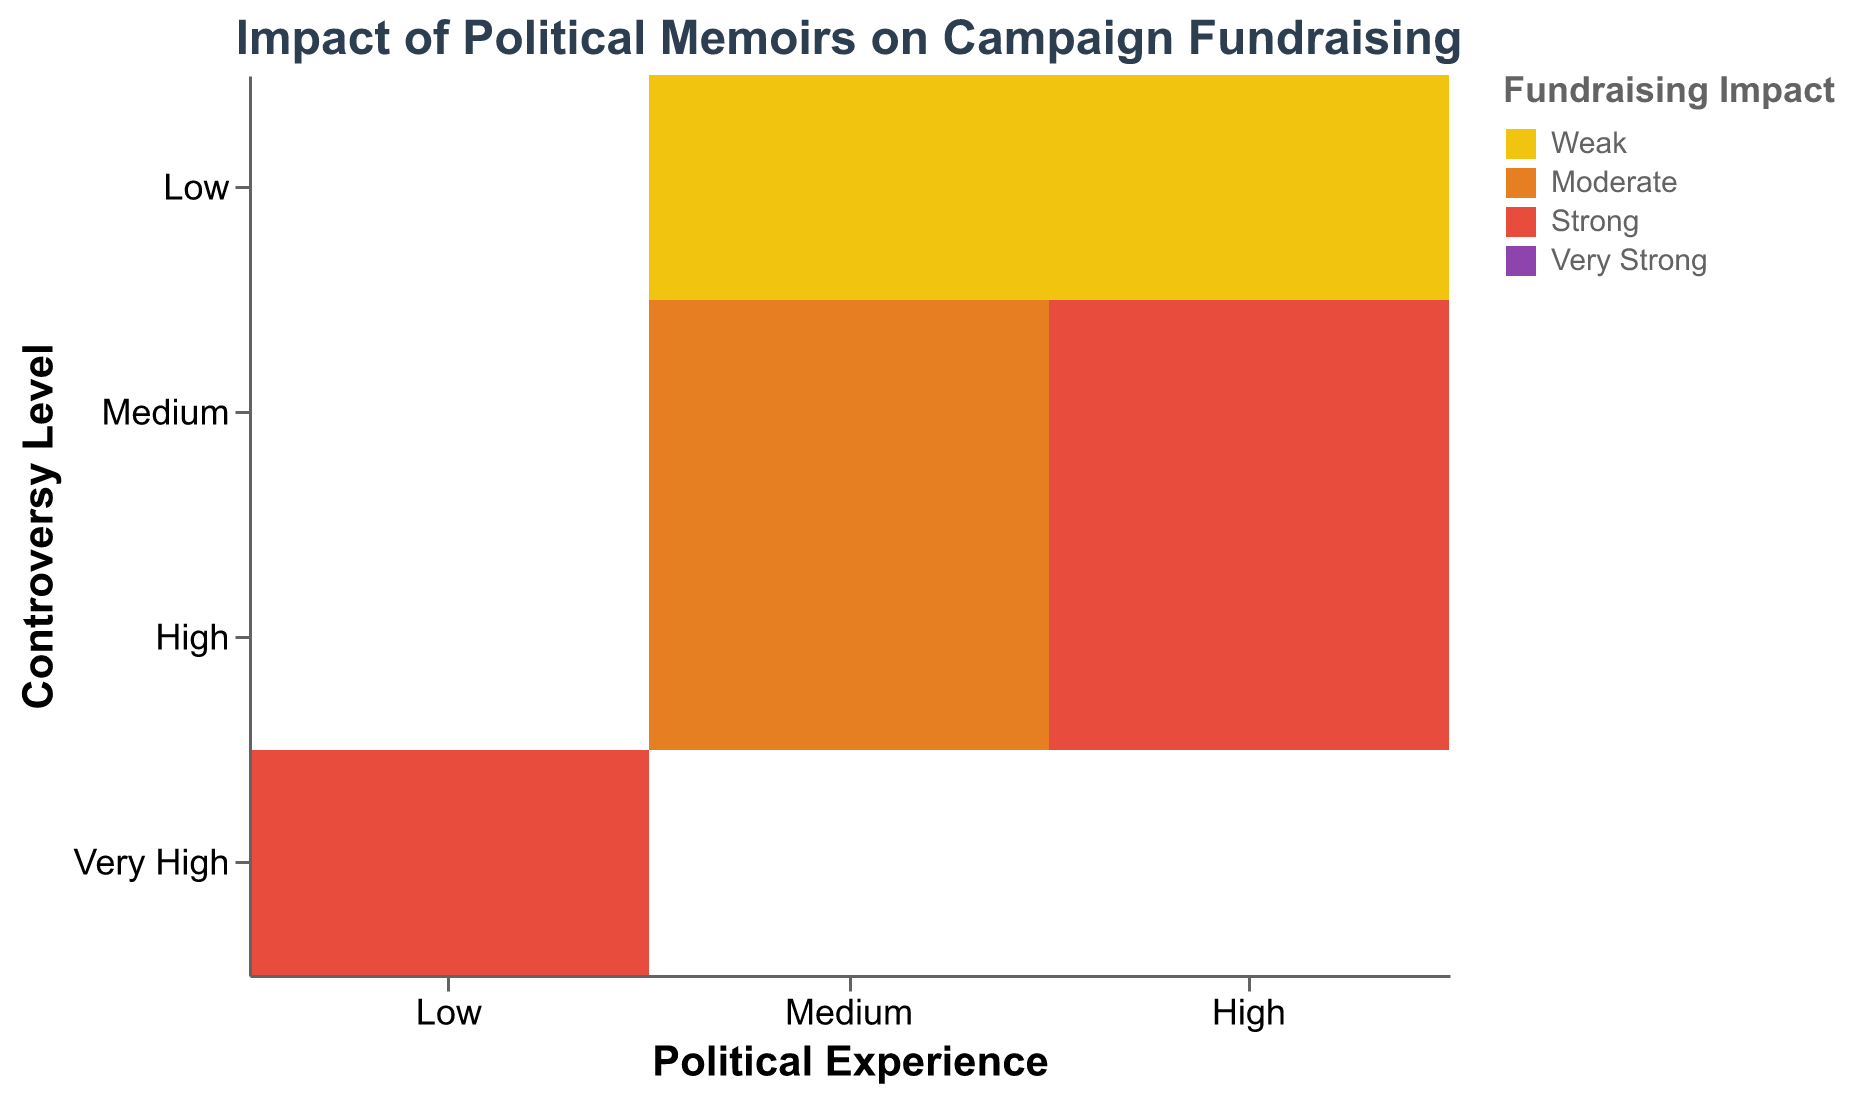What is the title of the figure? The title is displayed at the top of the figure, which summarizes the main topic.
Answer: Impact of Political Memoirs on Campaign Fundraising How many political memoirs have a 'Moderate' fundraising impact? Check the color legend and identify the color representing 'Moderate.' Then, count the number of rectangles in the figure with this color. There are four rectangles with the 'Moderate' color.
Answer: Four Which author with high political experience has a very strong fundraising impact? Look for the 'High' category under Political Experience on the x-axis, then check the color legend for 'Very Strong' (purple) in this category. Only Barack Obama's memoir fits this criterion.
Answer: Barack Obama What is the relationship between controversy level and fundraising impact for authors with medium political experience? Focus on the 'Medium' category under Political Experience, then examine how the colors vary across different levels of the y-axis (Controversy Level). Most memoirs with Medium Political Experience have a 'Moderate' or 'Weak' fundraising impact, regardless of controversy level.
Answer: Moderate/Weak Are there any authors with low political experience whose memoir has a weak fundraising impact? Scan the rectangles in the 'Low' category under Political Experience on the x-axis and identify any 'Weak' color (yellow). No rectangles match this criteria.
Answer: No Compare the fundraising impact of memoirs written by authors with high political experience versus medium political experience. Compare the color distributions between 'High' and 'Medium' categories under Political Experience on the x-axis to observe the differences. Authors with high political experience tend to have stronger fundraising impacts (strong or very strong), whereas those with medium experience lean towards moderate or weak fundraising impacts.
Answer: High has stronger impacts Which controversy level corresponds to a weak fundraising impact for high political experience? Examine the 'High' category under Political Experience, and look for the color representing 'Weak' (yellow) across different controversy levels. The label is 'Low.'
Answer: Low What is the typical fundraising impact for authors with medium political experience and medium controversy level? Locate the intersection of Medium Political Experience and Medium Controversy Level, then check the color of the rectangles at this intersection. This is typically 'Moderate' fundraising impact.
Answer: Moderate 